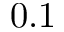Convert formula to latex. <formula><loc_0><loc_0><loc_500><loc_500>0 . 1</formula> 